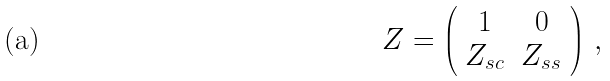Convert formula to latex. <formula><loc_0><loc_0><loc_500><loc_500>Z = \left ( \begin{array} { c c } 1 & 0 \\ Z _ { s c } & Z _ { s s } \end{array} \right ) \, ,</formula> 